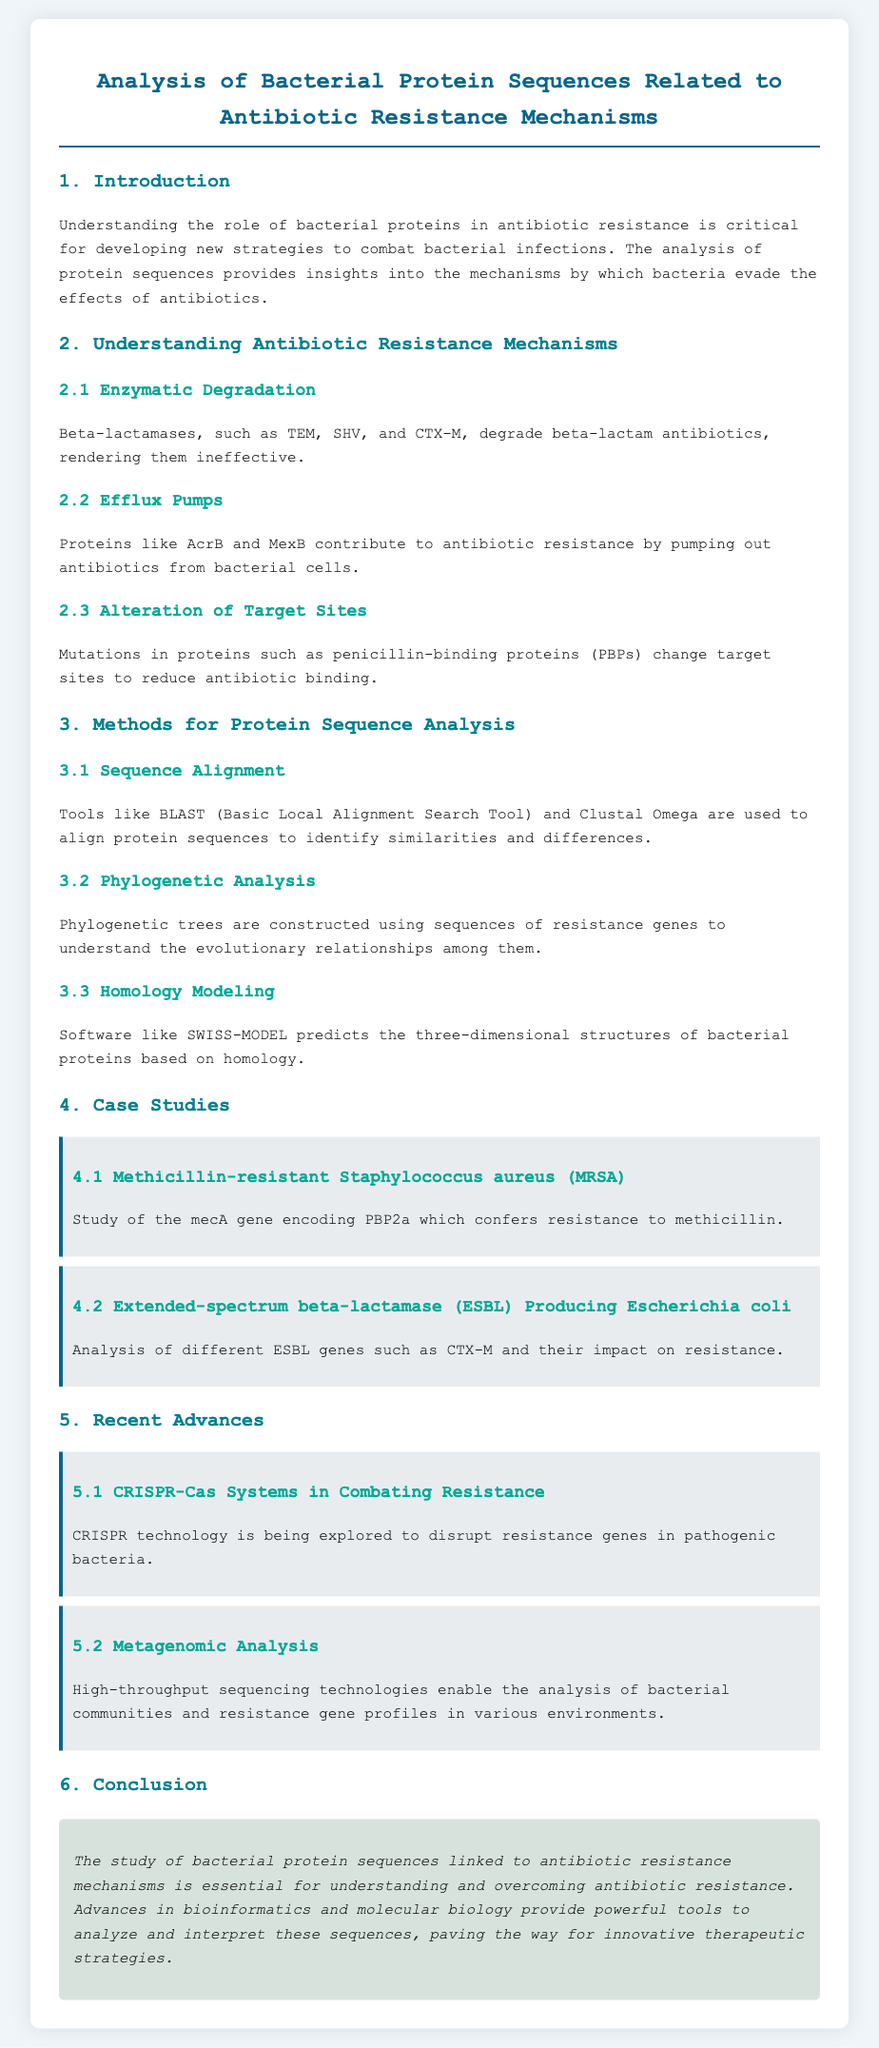What are the enzymatic degradation mechanisms discussed? The document mentions beta-lactamases that include TEM, SHV, and CTX-M as mechanisms of enzymatic degradation.
Answer: beta-lactamases (TEM, SHV, CTX-M) Which proteins are associated with efflux pumps? The document specifies AcrB and MexB as proteins contributing to antibiotic resistance through efflux pumps.
Answer: AcrB and MexB What method is used for sequence alignment? It is stated in the document that tools like BLAST and Clustal Omega are used for sequence alignment methods.
Answer: BLAST and Clustal Omega What is the focus of the case study on MRSA? The study on MRSA focuses on the mecA gene that encodes PBP2a, which confers resistance to methicillin.
Answer: mecA gene What recent technology is mentioned for combating resistance? The document discusses CRISPR technology being explored to disrupt resistance genes in pathogenic bacteria.
Answer: CRISPR technology Which high-throughput method is applied in metagenomic analysis? According to the document, high-throughput sequencing technologies are applied in metagenomic analysis of bacterial communities.
Answer: High-throughput sequencing technologies How does the document define the conclusion regarding bacterial protein sequences? The conclusion highlights the importance of studying bacterial protein sequences linked to antibiotic resistance mechanisms for understanding and overcoming resistance.
Answer: Understanding and overcoming antibiotic resistance What are the two main types of protein analysis methods mentioned? The document mentions sequence alignment and phylogenetic analysis as two main types of protein analysis methods.
Answer: Sequence alignment and phylogenetic analysis 